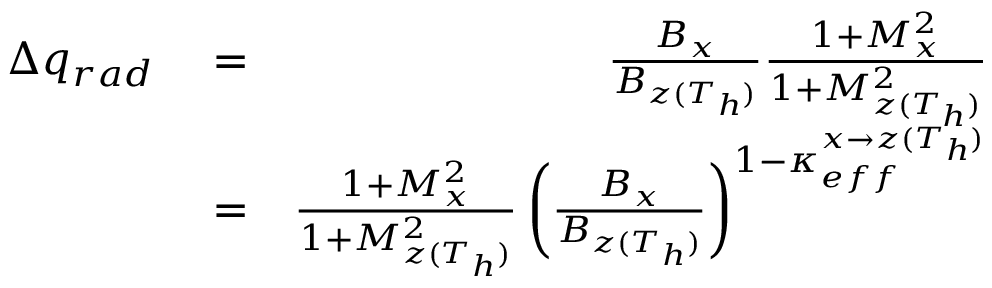<formula> <loc_0><loc_0><loc_500><loc_500>\begin{array} { r l r } { \Delta q _ { r a d } } & = } & { \frac { B _ { x } } { B _ { z ( T _ { h } ) } } \frac { 1 + M _ { x } ^ { 2 } } { 1 + M _ { z ( T _ { h } ) } ^ { 2 } } } & = } & { \frac { 1 + M _ { x } ^ { 2 } } { 1 + M _ { z ( T _ { h } ) } ^ { 2 } } \left ( \frac { B _ { x } } { B _ { z ( T _ { h } ) } } \right ) ^ { 1 - \kappa _ { e f f } ^ { x \rightarrow z ( T _ { h } ) } } } \end{array}</formula> 